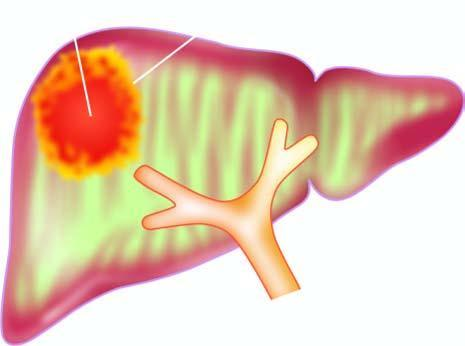s the centre irregular and necrotic?
Answer the question using a single word or phrase. No 